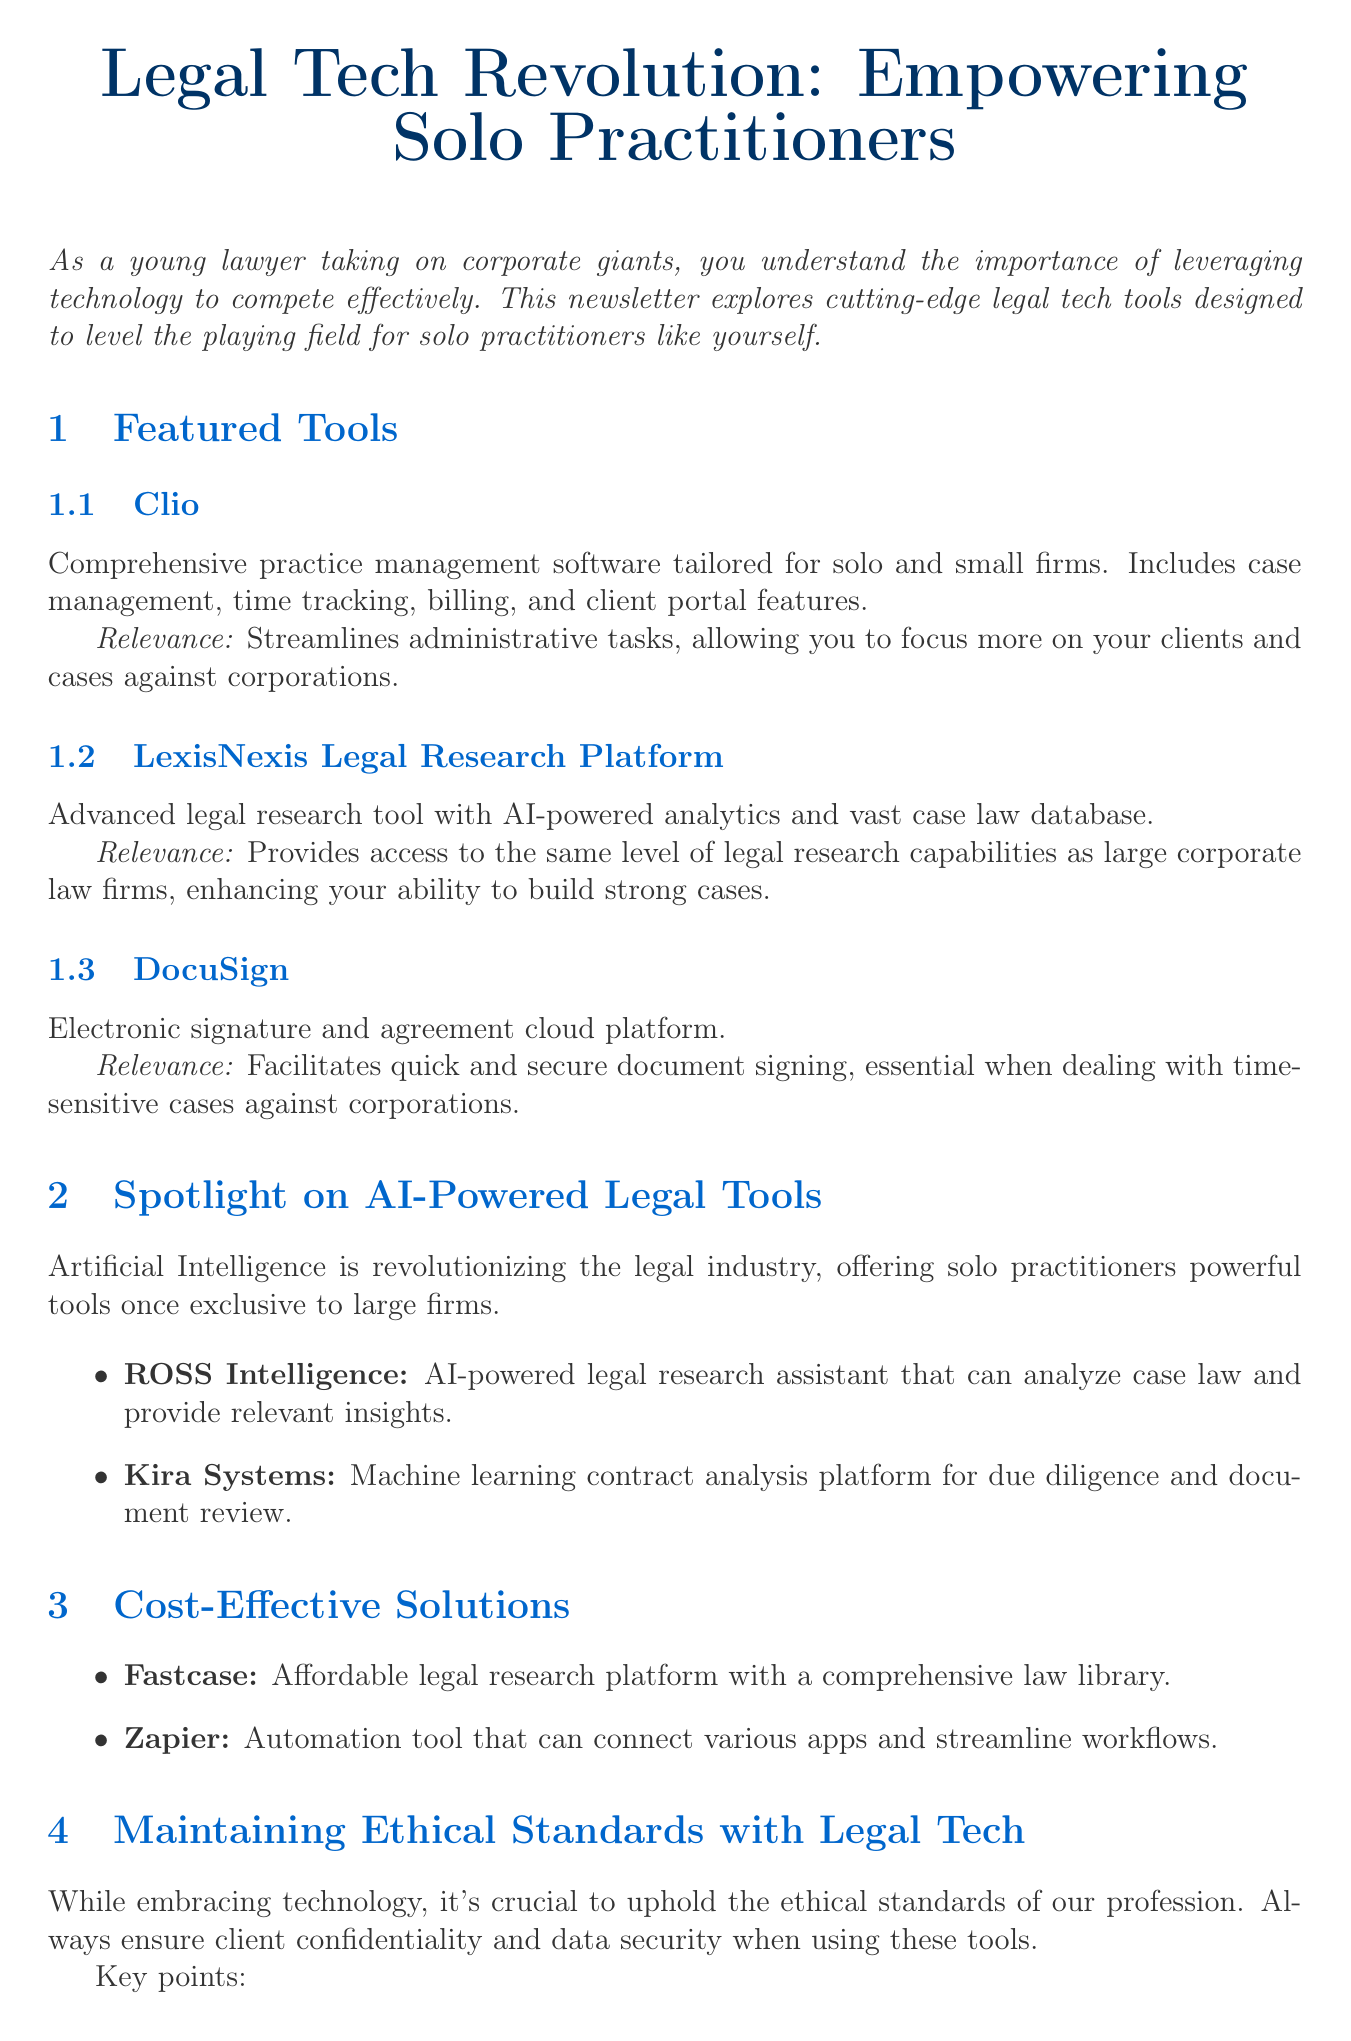What is the title of the newsletter? The title of the newsletter is stated at the beginning of the document.
Answer: Legal Tech Revolution: Empowering Solo Practitioners Which tool provides comprehensive practice management for solo practitioners? The document mentions a specific tool designed for practice management in the featured tools section.
Answer: Clio What is a benefit of using ROSS Intelligence? The document outlines the benefit of this AI-powered tool in the spotlight section.
Answer: Saves hours of research time What type of platform is DocuSign? The document categorizes DocuSign based on its functionality in the featured tools section.
Answer: Electronic signature and agreement cloud platform How many key points are listed for maintaining ethical standards? The document provides a specific number of key points regarding ethical standards.
Answer: Three 